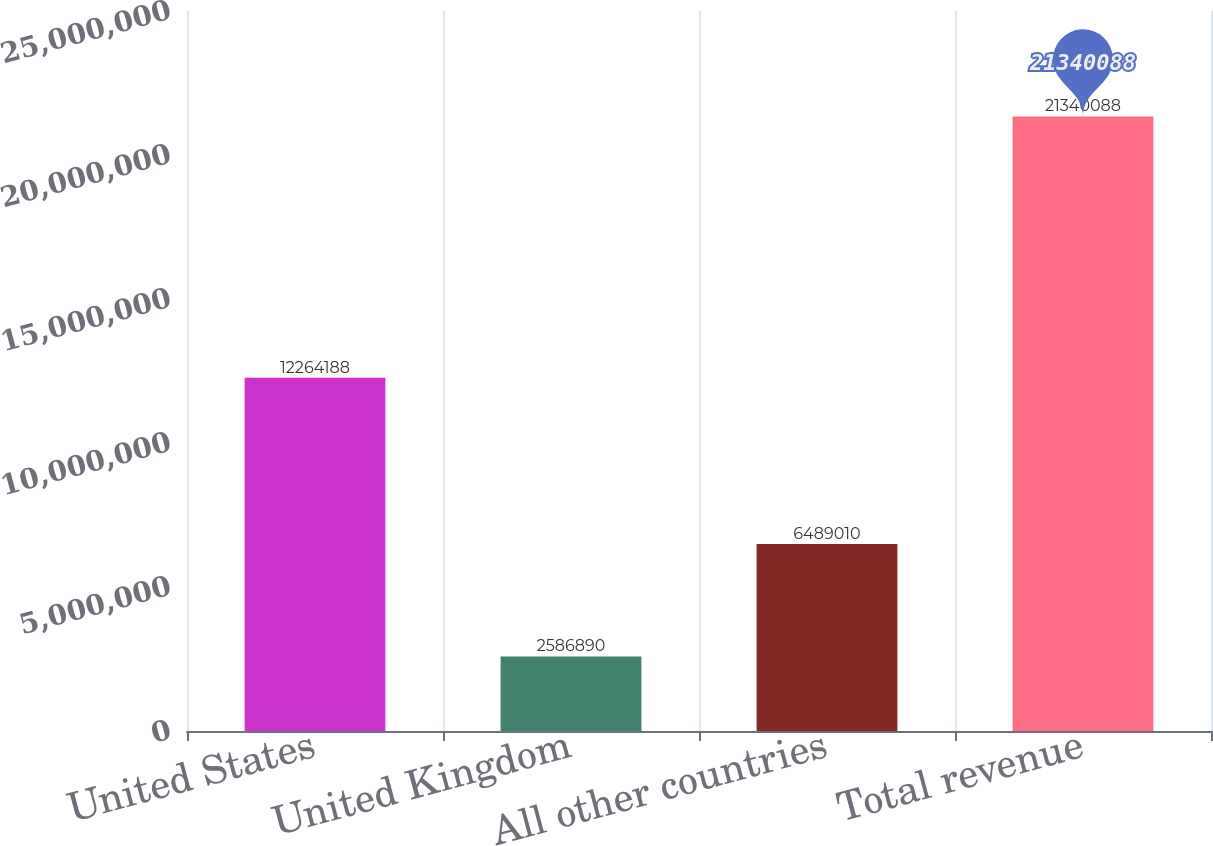Convert chart. <chart><loc_0><loc_0><loc_500><loc_500><bar_chart><fcel>United States<fcel>United Kingdom<fcel>All other countries<fcel>Total revenue<nl><fcel>1.22642e+07<fcel>2.58689e+06<fcel>6.48901e+06<fcel>2.13401e+07<nl></chart> 